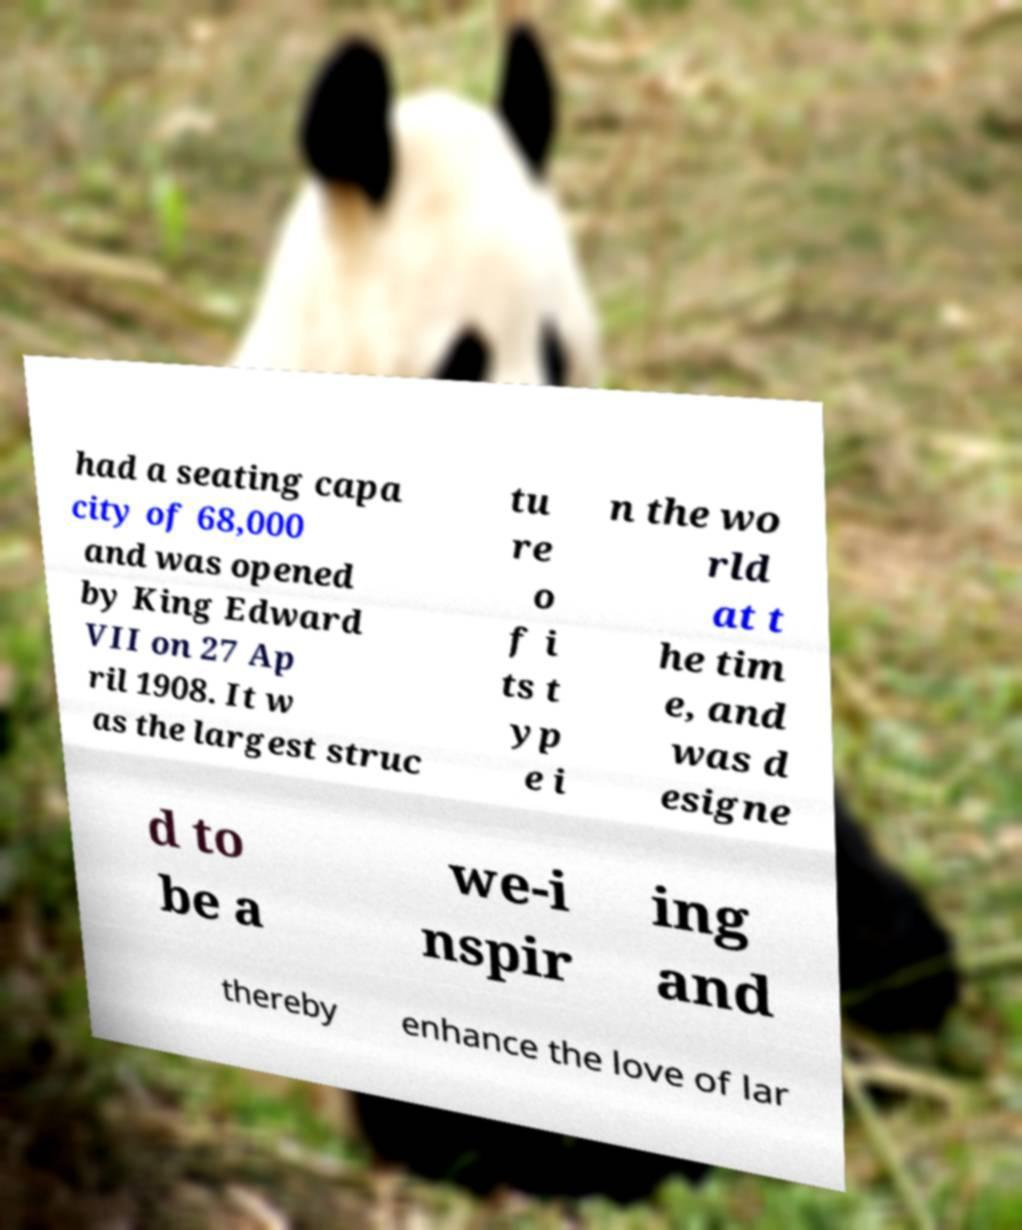What messages or text are displayed in this image? I need them in a readable, typed format. had a seating capa city of 68,000 and was opened by King Edward VII on 27 Ap ril 1908. It w as the largest struc tu re o f i ts t yp e i n the wo rld at t he tim e, and was d esigne d to be a we-i nspir ing and thereby enhance the love of lar 